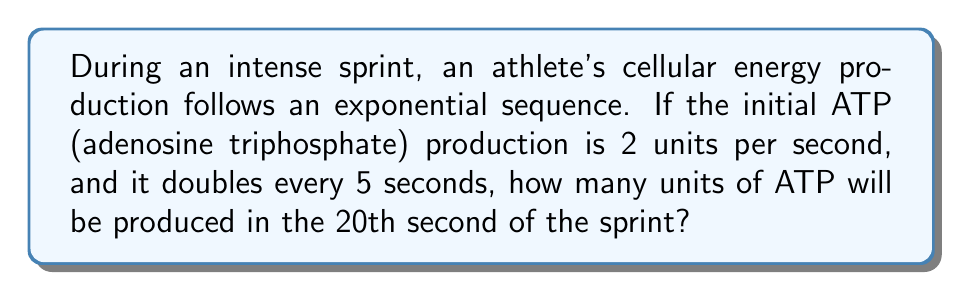Could you help me with this problem? Let's approach this step-by-step:

1) First, we need to identify the exponential sequence:
   Initial value: $a = 2$ units/second
   Common ratio: $r = 2$ (doubles every 5 seconds)
   
2) The general form of an exponential sequence is:
   $a_n = a \cdot r^n$, where $n$ is the number of times the value has doubled

3) We need to find how many times the value has doubled in 20 seconds:
   20 seconds ÷ 5 seconds per doubling = 4 doublings

4) Now we can plug this into our exponential sequence formula:
   $a_4 = 2 \cdot 2^4$

5) Let's calculate:
   $a_4 = 2 \cdot 2^4$
   $a_4 = 2 \cdot 16$
   $a_4 = 32$

Therefore, in the 20th second, the athlete's cells will produce 32 units of ATP per second.
Answer: 32 units 